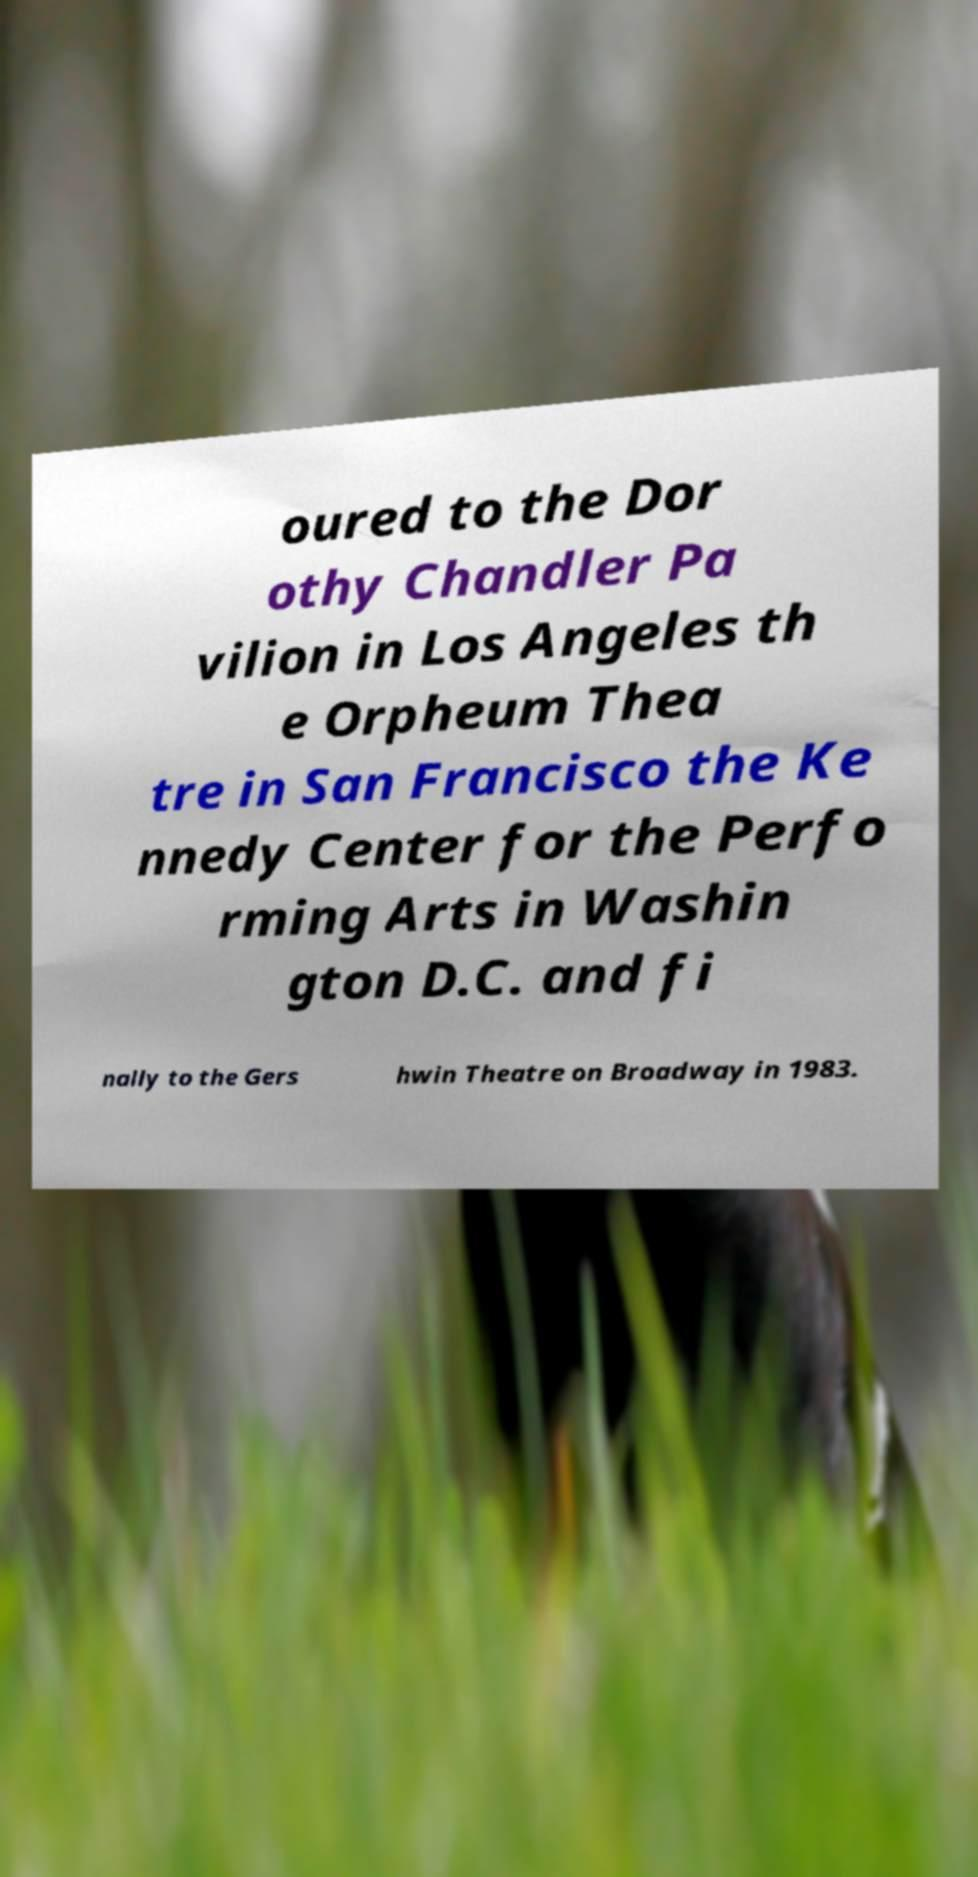Please identify and transcribe the text found in this image. oured to the Dor othy Chandler Pa vilion in Los Angeles th e Orpheum Thea tre in San Francisco the Ke nnedy Center for the Perfo rming Arts in Washin gton D.C. and fi nally to the Gers hwin Theatre on Broadway in 1983. 